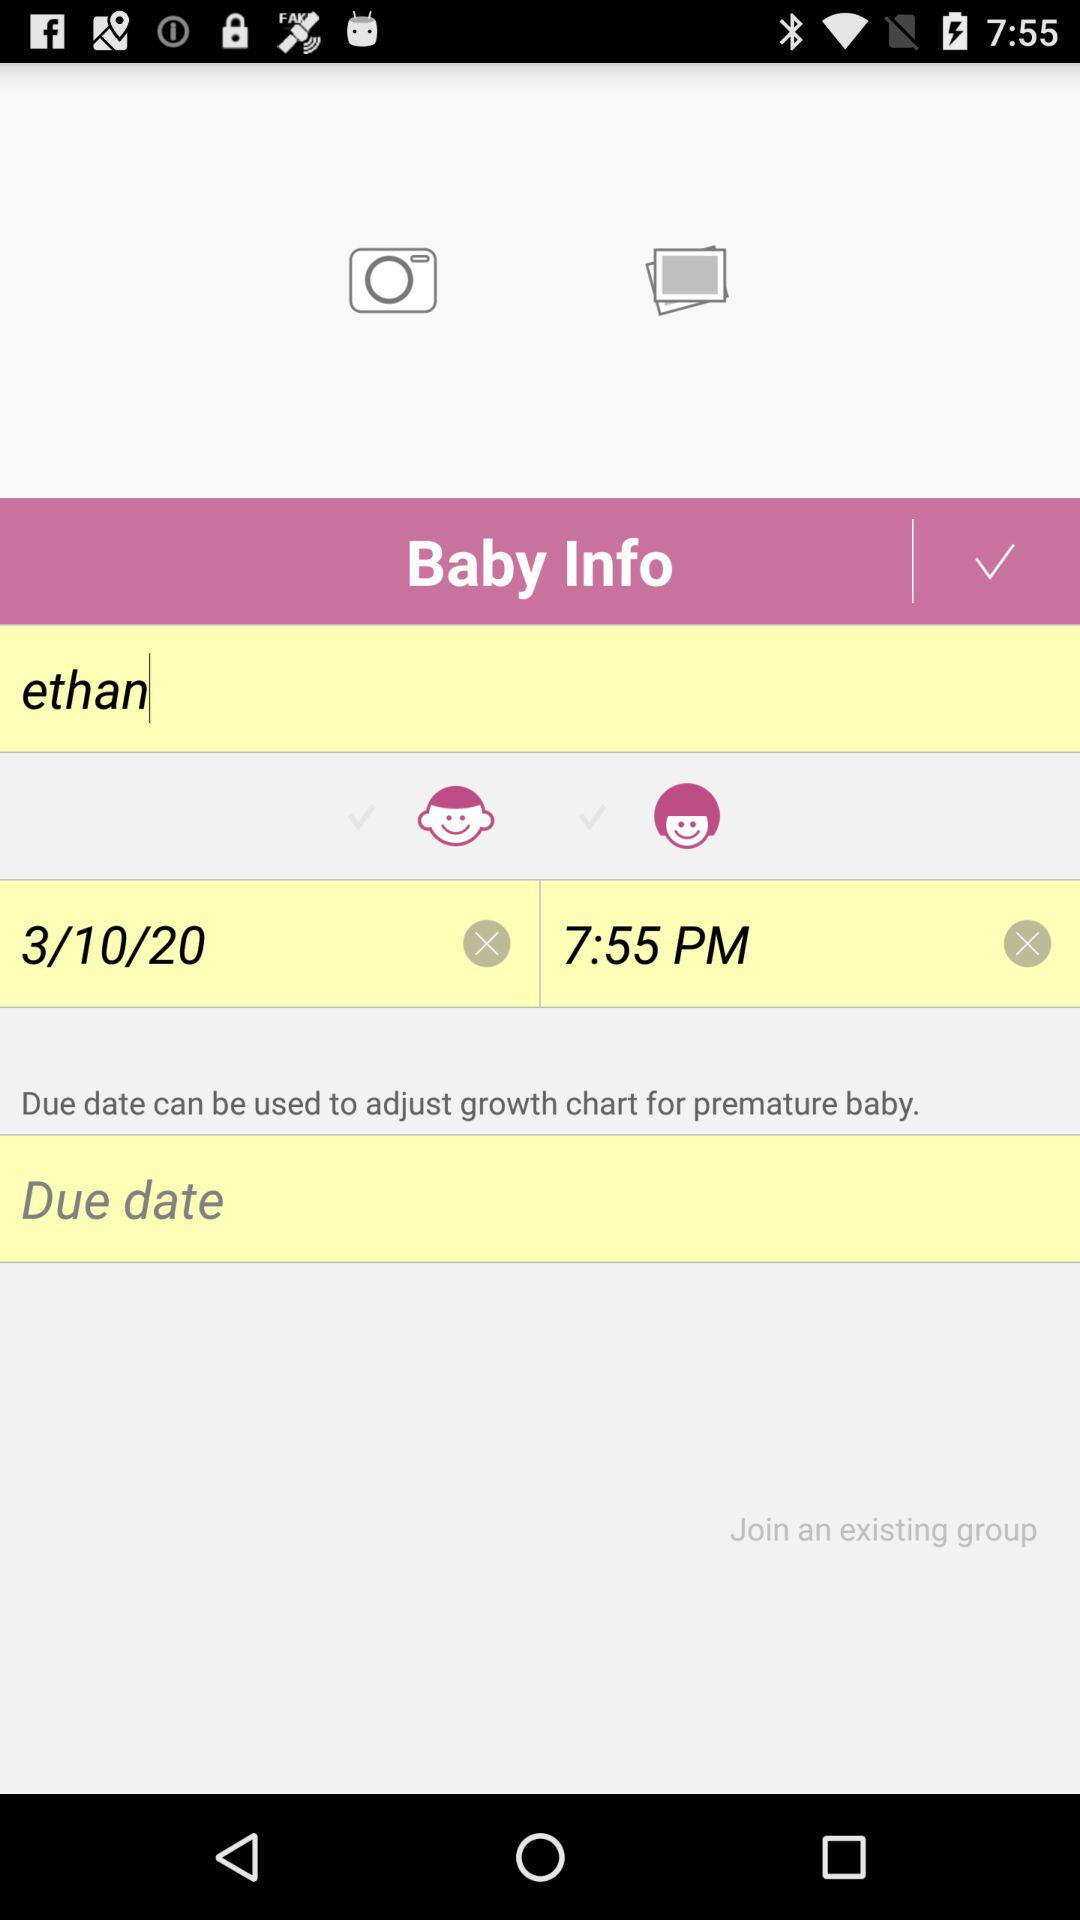When is the due date?
When the provided information is insufficient, respond with <no answer>. <no answer> 